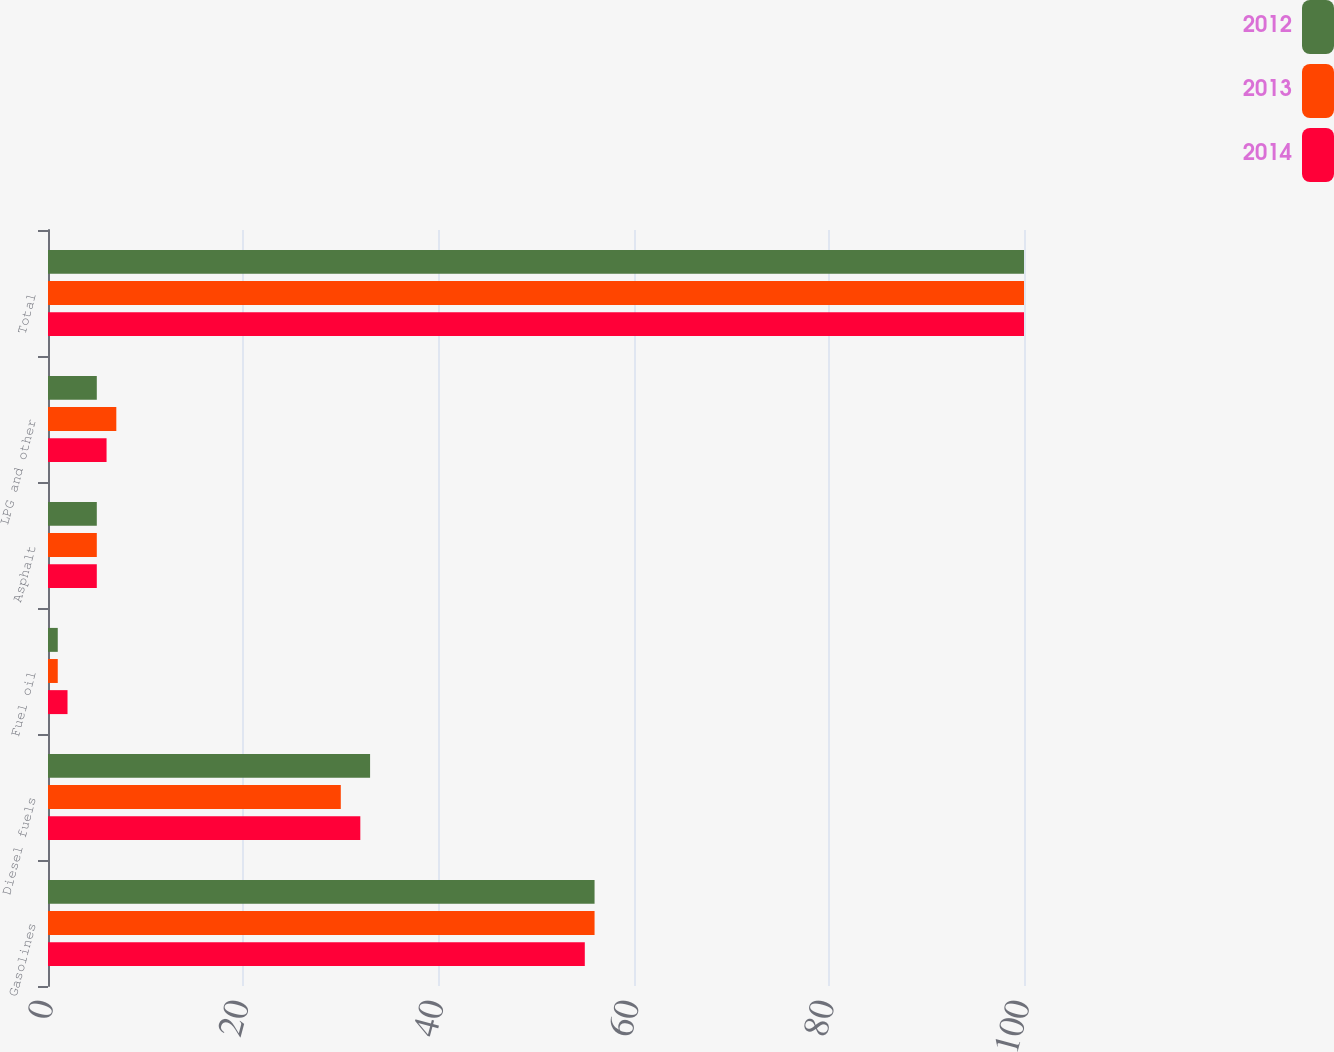<chart> <loc_0><loc_0><loc_500><loc_500><stacked_bar_chart><ecel><fcel>Gasolines<fcel>Diesel fuels<fcel>Fuel oil<fcel>Asphalt<fcel>LPG and other<fcel>Total<nl><fcel>2012<fcel>56<fcel>33<fcel>1<fcel>5<fcel>5<fcel>100<nl><fcel>2013<fcel>56<fcel>30<fcel>1<fcel>5<fcel>7<fcel>100<nl><fcel>2014<fcel>55<fcel>32<fcel>2<fcel>5<fcel>6<fcel>100<nl></chart> 